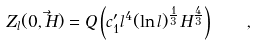<formula> <loc_0><loc_0><loc_500><loc_500>Z _ { l } ( 0 , \vec { H } ) = Q \left ( c _ { 1 } ^ { \prime } l ^ { 4 } ( \ln { l } ) ^ { \frac { 1 } { 3 } } H ^ { \frac { 4 } { 3 } } \right ) \quad ,</formula> 